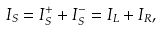<formula> <loc_0><loc_0><loc_500><loc_500>I _ { S } = I _ { S } ^ { + } + I _ { S } ^ { - } = I _ { L } + I _ { R } ,</formula> 